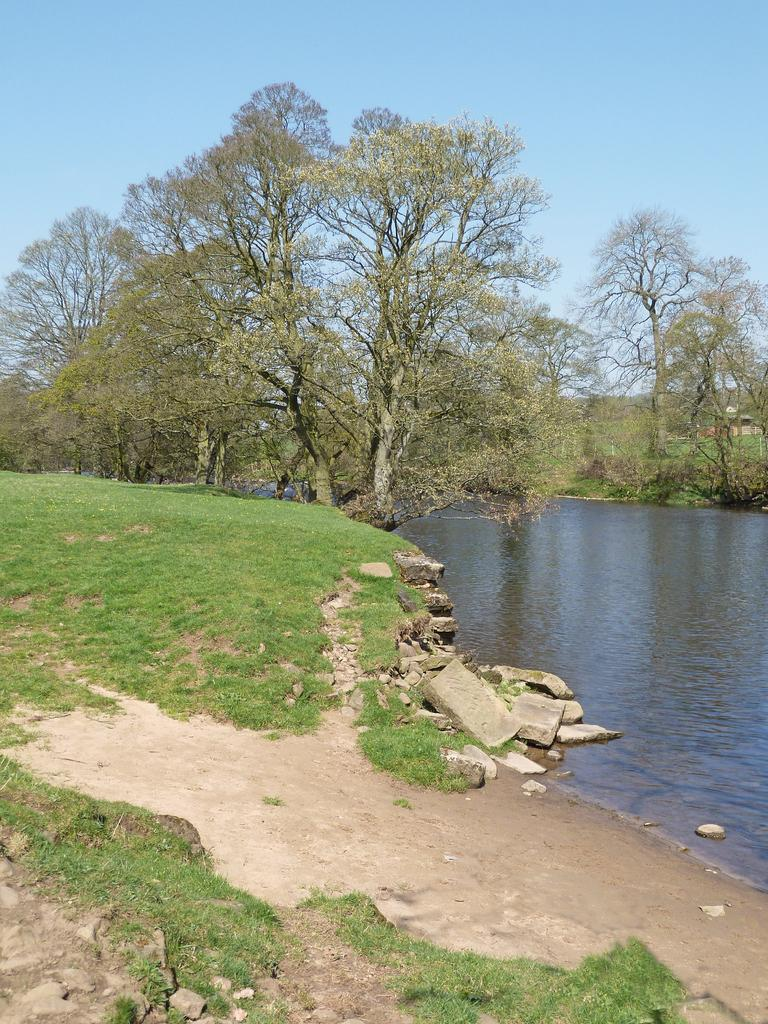What type of landscape is depicted in the image? There is a grassland in the image. What feature can be seen running through the grassland? There is a canal in the image. What surrounds the canal in the image? There are trees on either side of the canal. What can be seen in the distance in the image? The sky is visible in the background of the image. What type of jam is being spread on the ground in the image? There is no jam or any indication of spreading it in the image. Can you see a wrench being used in the image? There is no wrench or any tool usage depicted in the image. 